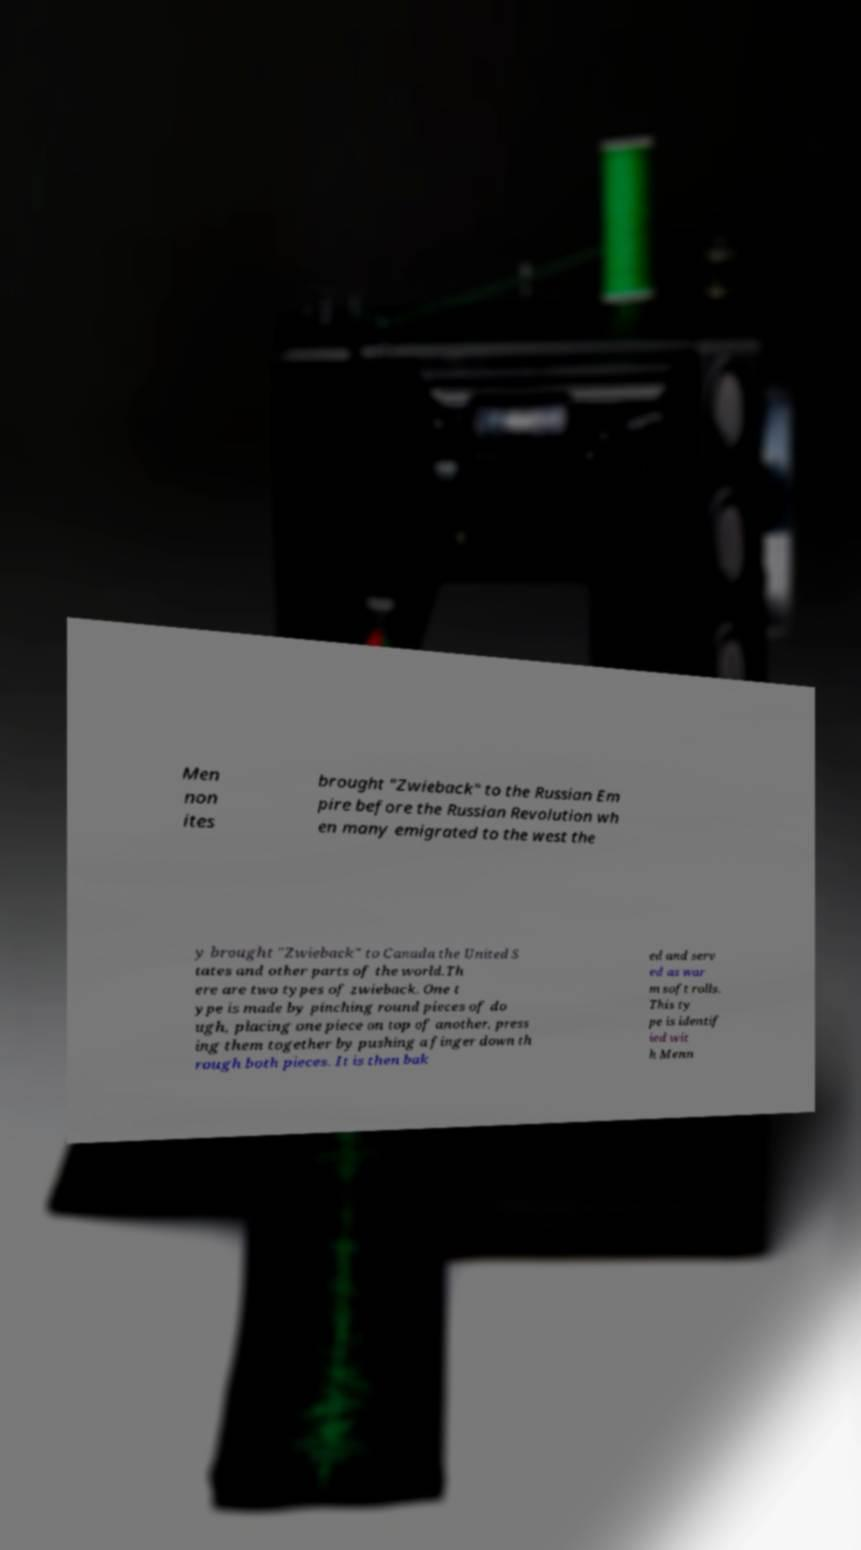I need the written content from this picture converted into text. Can you do that? Men non ites brought "Zwieback" to the Russian Em pire before the Russian Revolution wh en many emigrated to the west the y brought "Zwieback" to Canada the United S tates and other parts of the world.Th ere are two types of zwieback. One t ype is made by pinching round pieces of do ugh, placing one piece on top of another, press ing them together by pushing a finger down th rough both pieces. It is then bak ed and serv ed as war m soft rolls. This ty pe is identif ied wit h Menn 